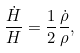Convert formula to latex. <formula><loc_0><loc_0><loc_500><loc_500>\frac { \dot { H } } { H } = \frac { 1 } { 2 } \frac { \dot { \rho } } { \rho } ,</formula> 